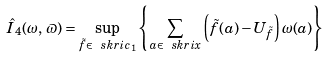<formula> <loc_0><loc_0><loc_500><loc_500>\hat { I } _ { 4 } ( \omega , \, \varpi ) = \sup _ { \tilde { f } \in \ s k r i c _ { 1 } } \left \{ \sum _ { a \in \ s k r i x } \left ( \tilde { f } ( a ) - U _ { \tilde { f } } \right ) \omega ( a ) \right \} \\</formula> 